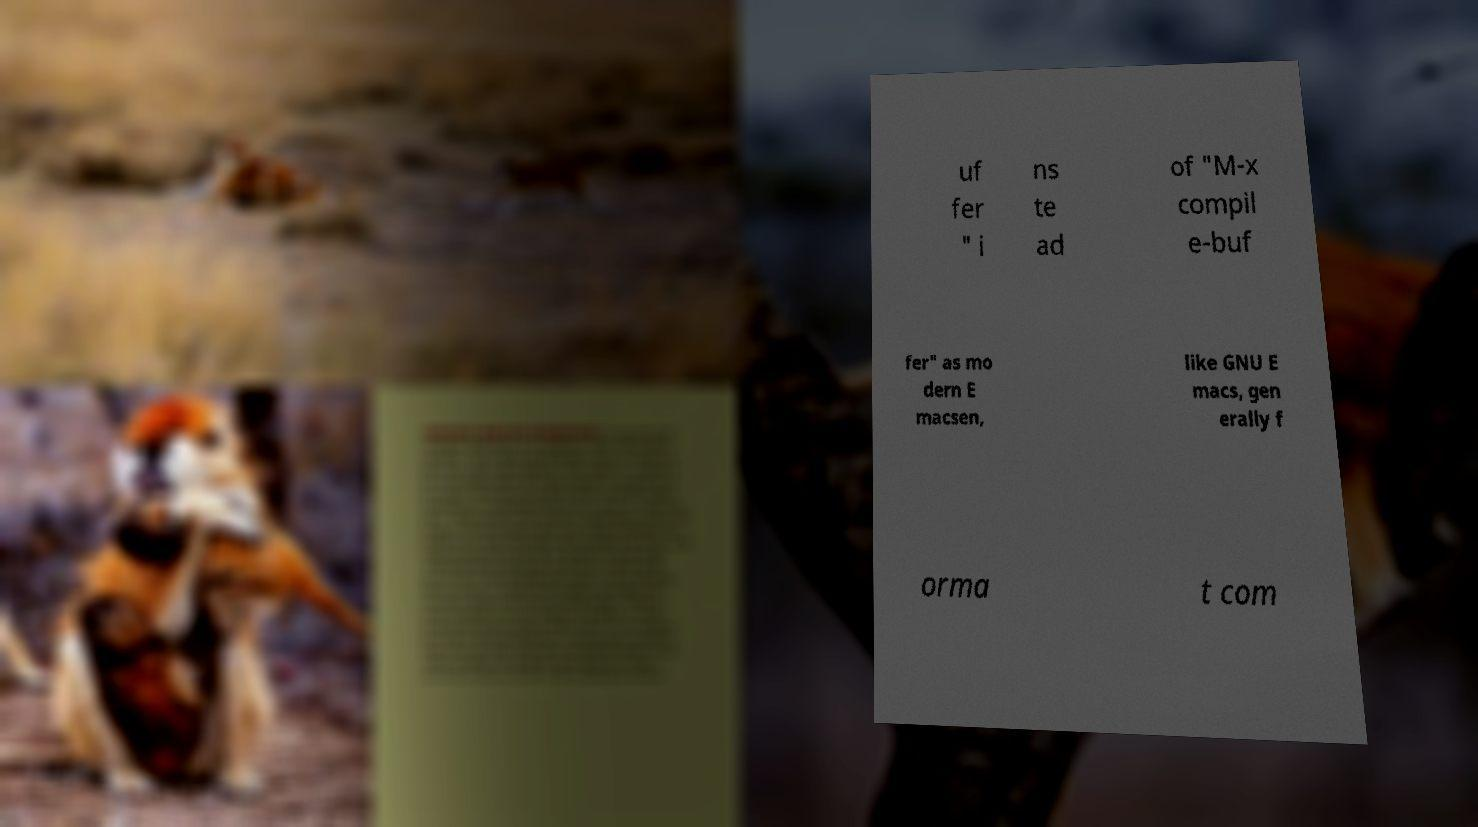What messages or text are displayed in this image? I need them in a readable, typed format. uf fer " i ns te ad of "M-x compil e-buf fer" as mo dern E macsen, like GNU E macs, gen erally f orma t com 